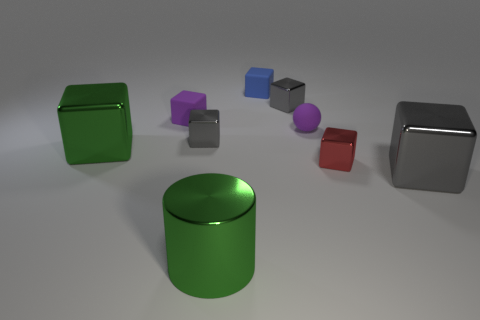Subtract all gray cubes. How many were subtracted if there are1gray cubes left? 2 Subtract all green balls. How many gray cubes are left? 3 Subtract all green blocks. How many blocks are left? 6 Subtract all purple cubes. How many cubes are left? 6 Subtract all purple blocks. Subtract all yellow balls. How many blocks are left? 6 Add 1 tiny blocks. How many objects exist? 10 Subtract all spheres. How many objects are left? 8 Add 4 green shiny blocks. How many green shiny blocks are left? 5 Add 5 small gray blocks. How many small gray blocks exist? 7 Subtract 0 cyan cubes. How many objects are left? 9 